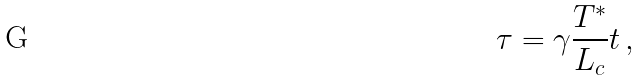<formula> <loc_0><loc_0><loc_500><loc_500>\tau = \gamma \frac { T ^ { \ast } } { L _ { c } } t \, ,</formula> 